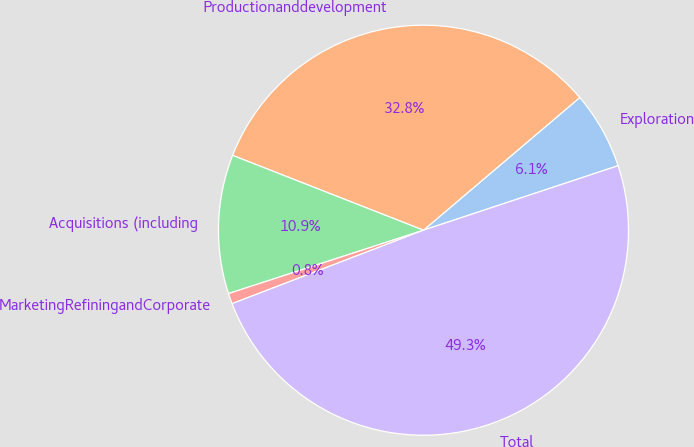Convert chart to OTSL. <chart><loc_0><loc_0><loc_500><loc_500><pie_chart><fcel>Exploration<fcel>Productionanddevelopment<fcel>Acquisitions (including<fcel>MarketingRefiningandCorporate<fcel>Total<nl><fcel>6.11%<fcel>32.85%<fcel>10.95%<fcel>0.83%<fcel>49.26%<nl></chart> 